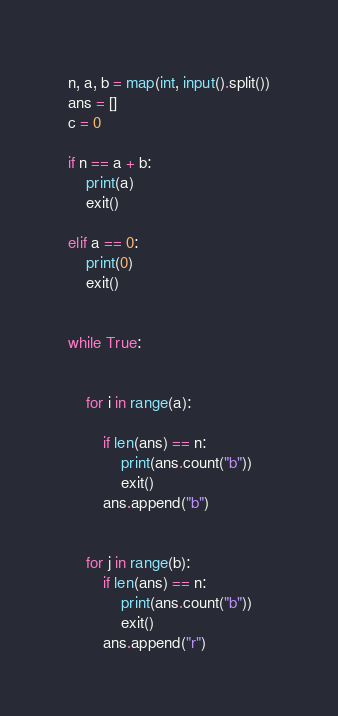Convert code to text. <code><loc_0><loc_0><loc_500><loc_500><_Python_>n, a, b = map(int, input().split())
ans = []
c = 0

if n == a + b:
    print(a)
    exit()

elif a == 0:
    print(0)
    exit()


while True:
    

    for i in range(a):
        
        if len(ans) == n:
            print(ans.count("b"))
            exit()
        ans.append("b")
        

    for j in range(b):
        if len(ans) == n:
            print(ans.count("b"))
            exit()
        ans.append("r")

</code> 